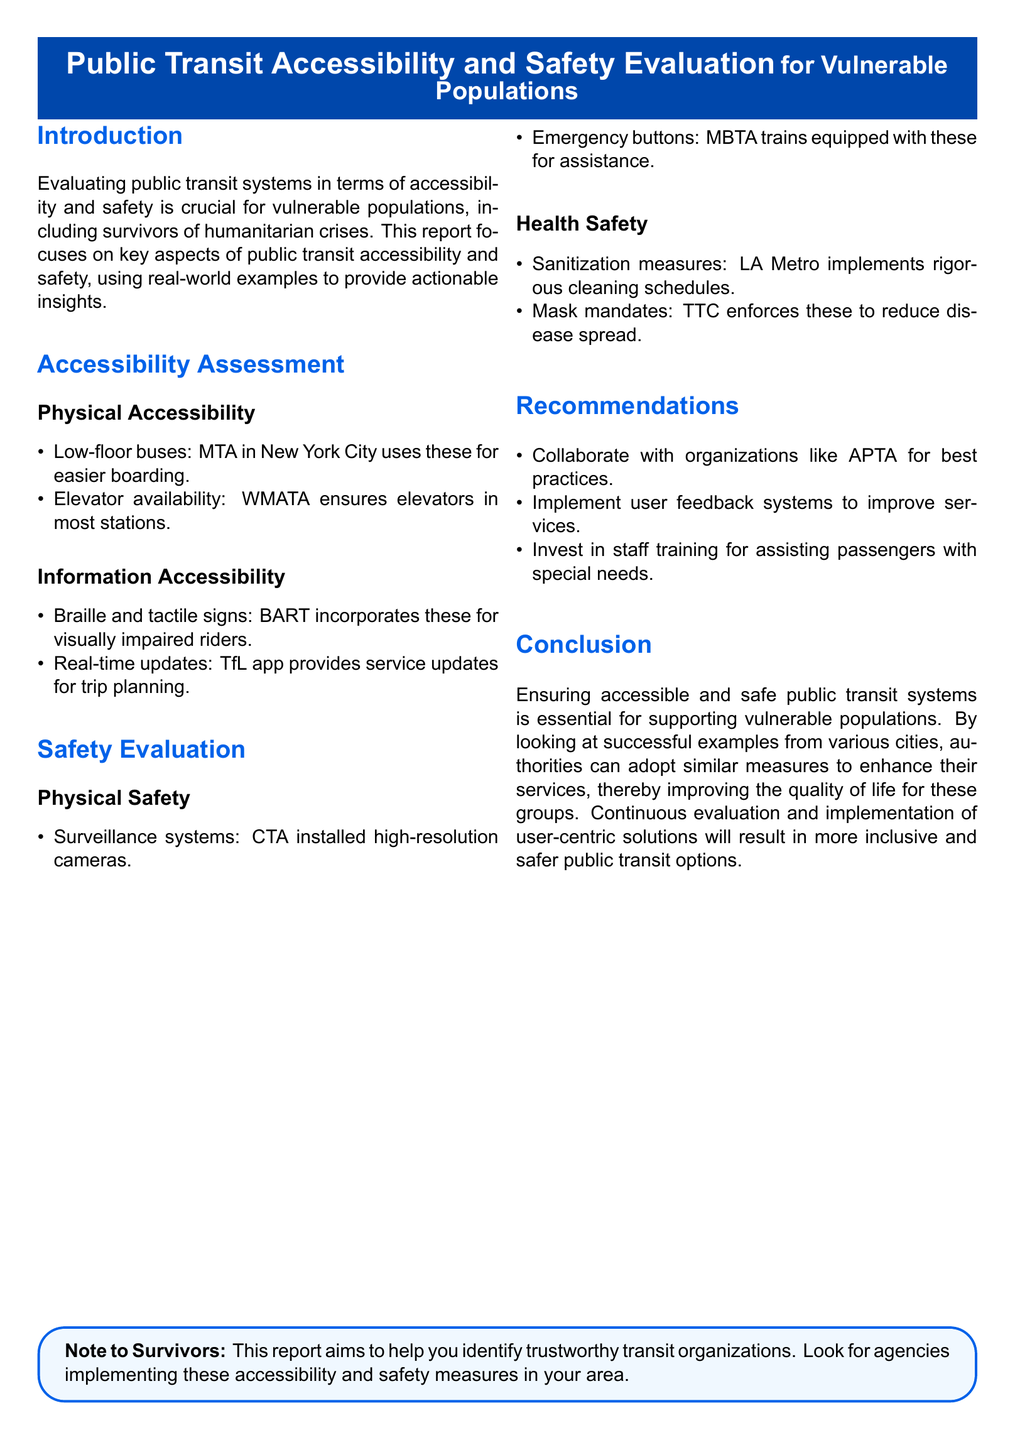what public transit system uses low-floor buses? The MTA in New York City uses low-floor buses for easier boarding.
Answer: MTA in New York City what type of signs does BART incorporate for visually impaired riders? BART incorporates Braille and tactile signs for visually impaired riders.
Answer: Braille and tactile signs which transit agency has installed high-resolution cameras for safety? The CTA has installed high-resolution cameras for physical safety.
Answer: CTA what measures does LA Metro implement for health safety? LA Metro implements rigorous cleaning schedules for sanitization.
Answer: rigorous cleaning schedules which organization is recommended for collaboration for best practices? The report recommends collaboration with APTA for best practices.
Answer: APTA how does TfL assist with real-time trip planning? The TfL app provides service updates for trip planning.
Answer: TfL app what equipment is mentioned in MBTA trains for assistance? MBTA trains are equipped with emergency buttons for assistance.
Answer: emergency buttons what mandates does TTC enforce to reduce disease spread? TTC enforces mask mandates to reduce disease spread.
Answer: mask mandates how should authorities improve transit services according to recommendations? Authorities should implement user feedback systems to improve services.
Answer: user feedback systems 